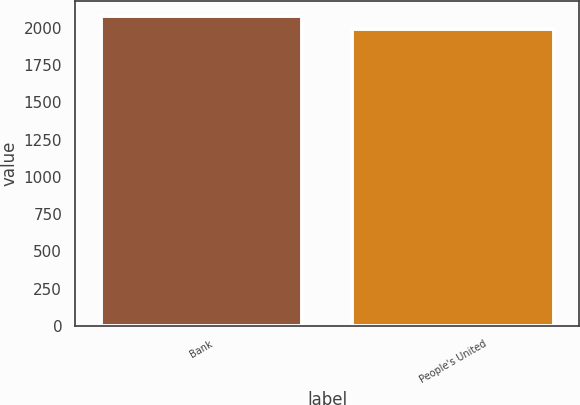Convert chart. <chart><loc_0><loc_0><loc_500><loc_500><bar_chart><fcel>Bank<fcel>People's United<nl><fcel>2078.7<fcel>1995.4<nl></chart> 